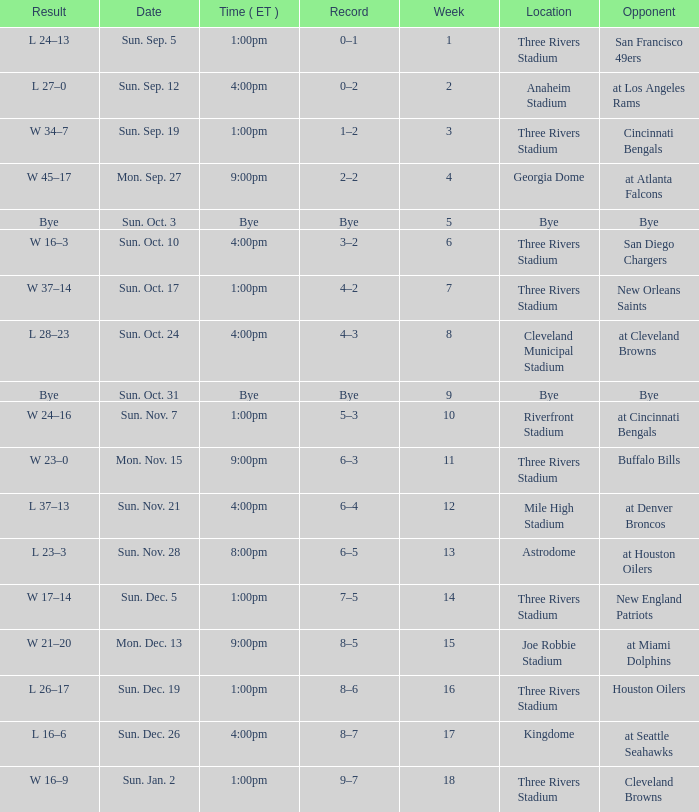What is the earliest week that shows a record of 8–5? 15.0. 